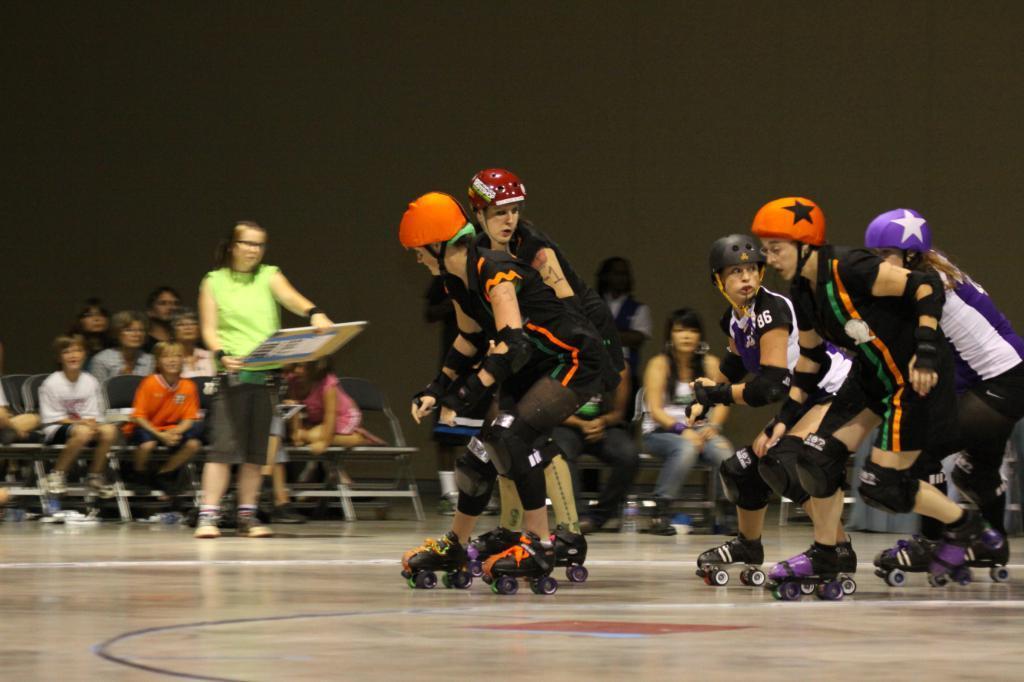Could you give a brief overview of what you see in this image? In this image I can see group of people skating and they are wearing multi color helmets. In the background I can see few people, some are sitting and some are standing. 